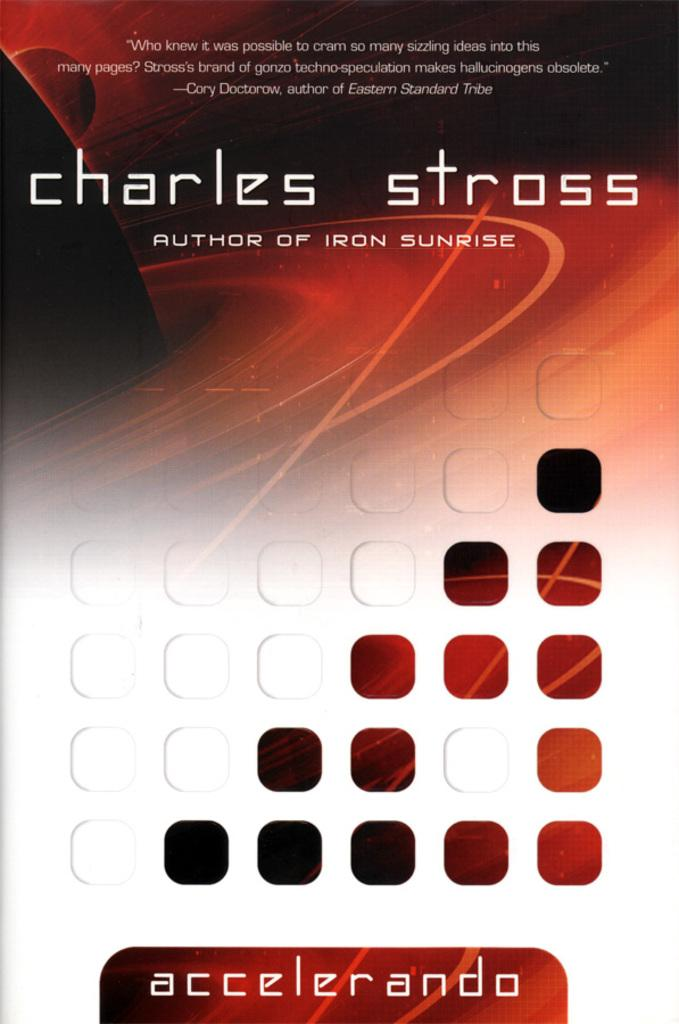<image>
Write a terse but informative summary of the picture. a book cover that says 'charles stross author of iron sunrise' 